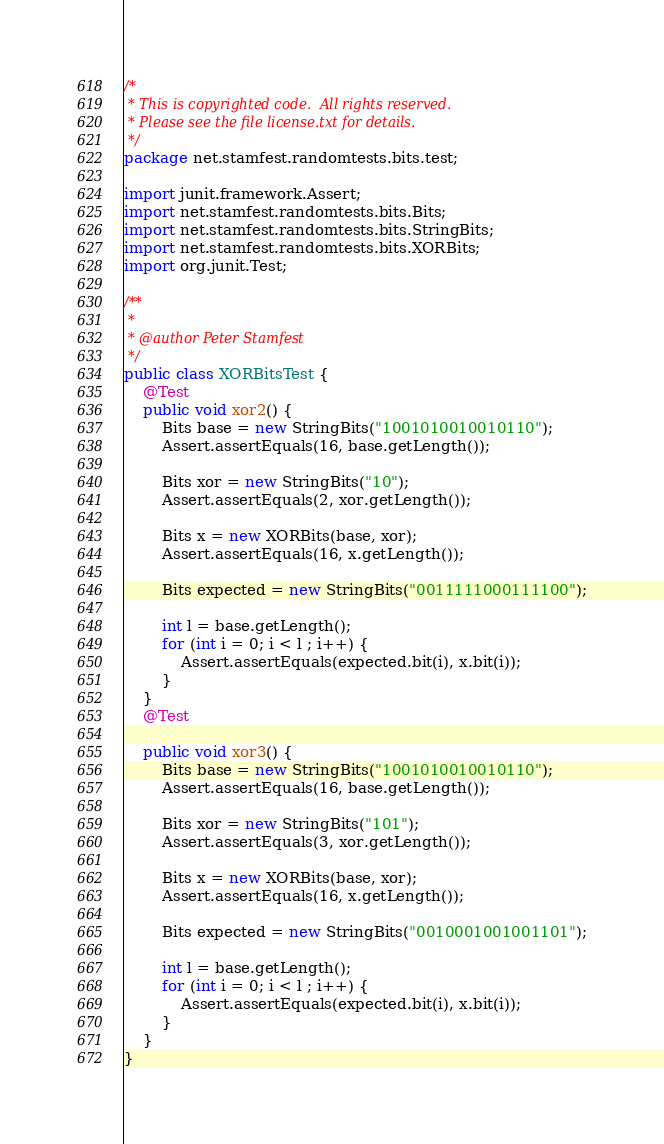Convert code to text. <code><loc_0><loc_0><loc_500><loc_500><_Java_>/*
 * This is copyrighted code.  All rights reserved.
 * Please see the file license.txt for details.
 */
package net.stamfest.randomtests.bits.test;

import junit.framework.Assert;
import net.stamfest.randomtests.bits.Bits;
import net.stamfest.randomtests.bits.StringBits;
import net.stamfest.randomtests.bits.XORBits;
import org.junit.Test;

/**
 *
 * @author Peter Stamfest
 */
public class XORBitsTest {
    @Test
    public void xor2() {
        Bits base = new StringBits("1001010010010110");
        Assert.assertEquals(16, base.getLength());

        Bits xor = new StringBits("10");
        Assert.assertEquals(2, xor.getLength());

        Bits x = new XORBits(base, xor);
        Assert.assertEquals(16, x.getLength());

        Bits expected = new StringBits("0011111000111100");

        int l = base.getLength();
        for (int i = 0; i < l ; i++) {
            Assert.assertEquals(expected.bit(i), x.bit(i));
        }
    }
    @Test
    
    public void xor3() {
        Bits base = new StringBits("1001010010010110");
        Assert.assertEquals(16, base.getLength());

        Bits xor = new StringBits("101");
        Assert.assertEquals(3, xor.getLength());

        Bits x = new XORBits(base, xor);
        Assert.assertEquals(16, x.getLength());

        Bits expected = new StringBits("0010001001001101");

        int l = base.getLength();
        for (int i = 0; i < l ; i++) {
            Assert.assertEquals(expected.bit(i), x.bit(i));
        }
    }
}
</code> 